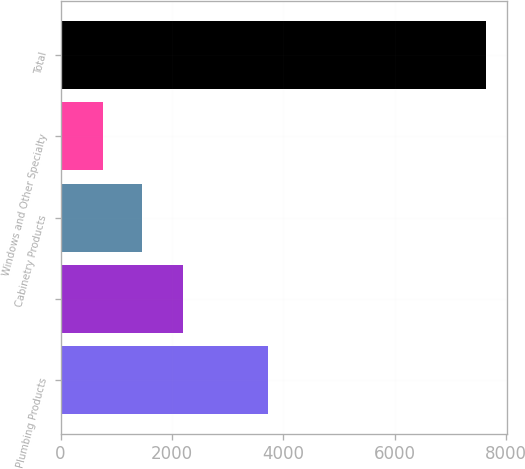<chart> <loc_0><loc_0><loc_500><loc_500><bar_chart><fcel>Plumbing Products<fcel>Unnamed: 1<fcel>Cabinetry Products<fcel>Windows and Other Specialty<fcel>Total<nl><fcel>3735<fcel>2205<fcel>1457.4<fcel>770<fcel>7644<nl></chart> 